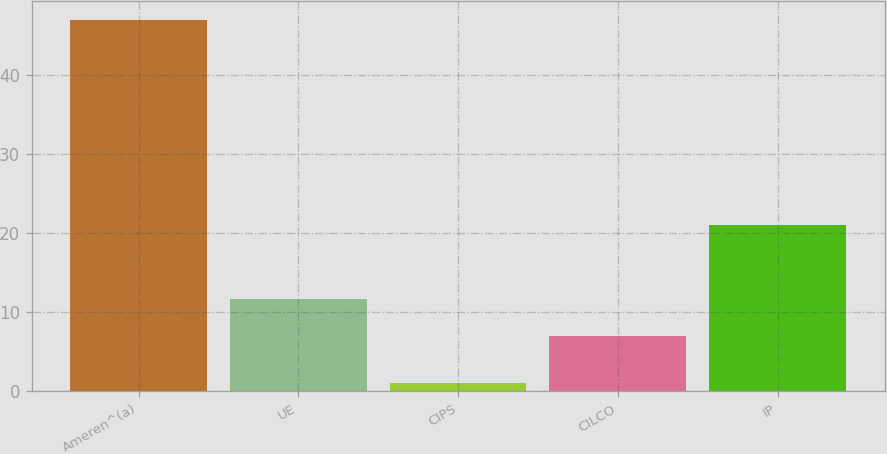Convert chart. <chart><loc_0><loc_0><loc_500><loc_500><bar_chart><fcel>Ameren^(a)<fcel>UE<fcel>CIPS<fcel>CILCO<fcel>IP<nl><fcel>47<fcel>11.6<fcel>1<fcel>7<fcel>21<nl></chart> 